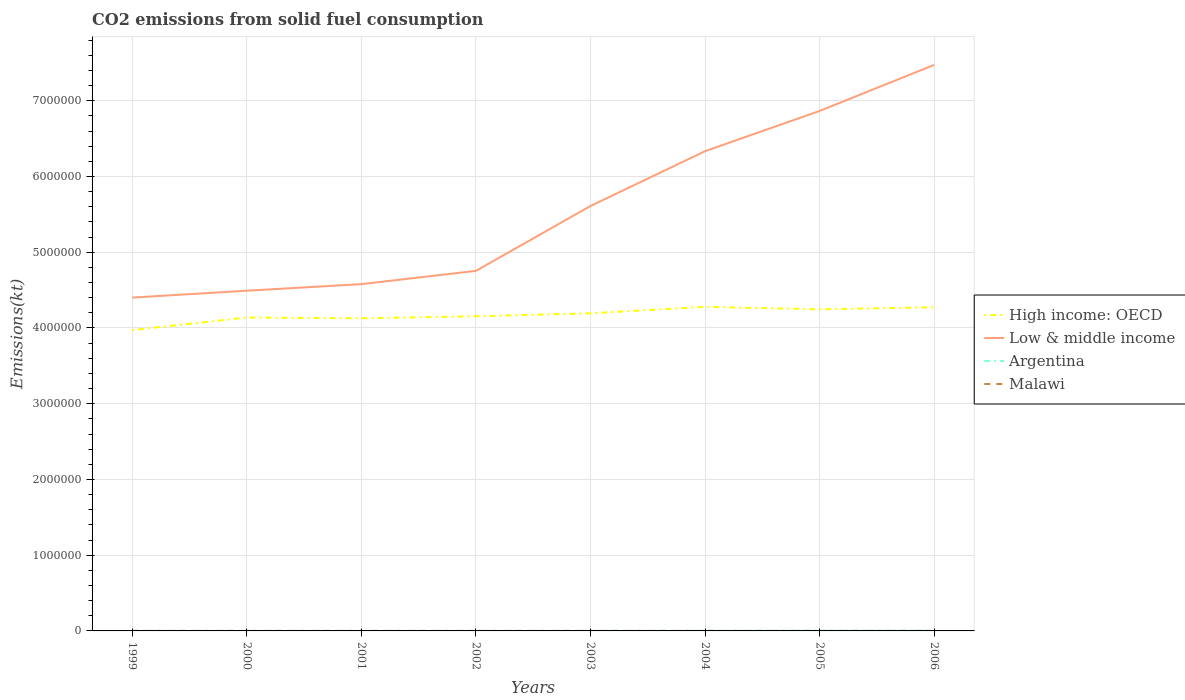Does the line corresponding to Argentina intersect with the line corresponding to Low & middle income?
Your answer should be compact. No. Across all years, what is the maximum amount of CO2 emitted in Low & middle income?
Your response must be concise. 4.40e+06. What is the total amount of CO2 emitted in Argentina in the graph?
Offer a very short reply. -891.08. What is the difference between the highest and the second highest amount of CO2 emitted in Argentina?
Your response must be concise. 2768.59. Is the amount of CO2 emitted in Argentina strictly greater than the amount of CO2 emitted in Low & middle income over the years?
Make the answer very short. Yes. How many lines are there?
Your response must be concise. 4. Are the values on the major ticks of Y-axis written in scientific E-notation?
Provide a succinct answer. No. Does the graph contain any zero values?
Offer a very short reply. No. Does the graph contain grids?
Your answer should be compact. Yes. What is the title of the graph?
Keep it short and to the point. CO2 emissions from solid fuel consumption. Does "Kenya" appear as one of the legend labels in the graph?
Give a very brief answer. No. What is the label or title of the Y-axis?
Your response must be concise. Emissions(kt). What is the Emissions(kt) of High income: OECD in 1999?
Your answer should be compact. 3.97e+06. What is the Emissions(kt) in Low & middle income in 1999?
Your response must be concise. 4.40e+06. What is the Emissions(kt) in Argentina in 1999?
Give a very brief answer. 2156.2. What is the Emissions(kt) of Malawi in 1999?
Provide a succinct answer. 143.01. What is the Emissions(kt) of High income: OECD in 2000?
Provide a short and direct response. 4.14e+06. What is the Emissions(kt) in Low & middle income in 2000?
Your answer should be very brief. 4.49e+06. What is the Emissions(kt) in Argentina in 2000?
Ensure brevity in your answer.  1657.48. What is the Emissions(kt) of Malawi in 2000?
Ensure brevity in your answer.  168.68. What is the Emissions(kt) of High income: OECD in 2001?
Keep it short and to the point. 4.13e+06. What is the Emissions(kt) of Low & middle income in 2001?
Offer a very short reply. 4.58e+06. What is the Emissions(kt) in Argentina in 2001?
Keep it short and to the point. 1290.78. What is the Emissions(kt) of Malawi in 2001?
Your response must be concise. 121.01. What is the Emissions(kt) of High income: OECD in 2002?
Offer a terse response. 4.15e+06. What is the Emissions(kt) in Low & middle income in 2002?
Your answer should be compact. 4.75e+06. What is the Emissions(kt) of Argentina in 2002?
Give a very brief answer. 1100.1. What is the Emissions(kt) of Malawi in 2002?
Your answer should be very brief. 179.68. What is the Emissions(kt) of High income: OECD in 2003?
Offer a terse response. 4.19e+06. What is the Emissions(kt) of Low & middle income in 2003?
Make the answer very short. 5.61e+06. What is the Emissions(kt) of Argentina in 2003?
Provide a succinct answer. 1991.18. What is the Emissions(kt) of Malawi in 2003?
Offer a very short reply. 168.68. What is the Emissions(kt) of High income: OECD in 2004?
Offer a terse response. 4.28e+06. What is the Emissions(kt) of Low & middle income in 2004?
Ensure brevity in your answer.  6.33e+06. What is the Emissions(kt) in Argentina in 2004?
Provide a succinct answer. 2200.2. What is the Emissions(kt) in Malawi in 2004?
Give a very brief answer. 161.35. What is the Emissions(kt) in High income: OECD in 2005?
Provide a succinct answer. 4.25e+06. What is the Emissions(kt) of Low & middle income in 2005?
Give a very brief answer. 6.87e+06. What is the Emissions(kt) of Argentina in 2005?
Your response must be concise. 3270.96. What is the Emissions(kt) in Malawi in 2005?
Provide a short and direct response. 157.68. What is the Emissions(kt) in High income: OECD in 2006?
Your answer should be very brief. 4.27e+06. What is the Emissions(kt) in Low & middle income in 2006?
Your response must be concise. 7.47e+06. What is the Emissions(kt) of Argentina in 2006?
Provide a succinct answer. 3868.68. What is the Emissions(kt) of Malawi in 2006?
Your answer should be compact. 157.68. Across all years, what is the maximum Emissions(kt) in High income: OECD?
Offer a terse response. 4.28e+06. Across all years, what is the maximum Emissions(kt) of Low & middle income?
Provide a short and direct response. 7.47e+06. Across all years, what is the maximum Emissions(kt) in Argentina?
Your answer should be very brief. 3868.68. Across all years, what is the maximum Emissions(kt) in Malawi?
Keep it short and to the point. 179.68. Across all years, what is the minimum Emissions(kt) in High income: OECD?
Ensure brevity in your answer.  3.97e+06. Across all years, what is the minimum Emissions(kt) in Low & middle income?
Your response must be concise. 4.40e+06. Across all years, what is the minimum Emissions(kt) of Argentina?
Provide a succinct answer. 1100.1. Across all years, what is the minimum Emissions(kt) of Malawi?
Make the answer very short. 121.01. What is the total Emissions(kt) of High income: OECD in the graph?
Provide a succinct answer. 3.34e+07. What is the total Emissions(kt) of Low & middle income in the graph?
Provide a succinct answer. 4.45e+07. What is the total Emissions(kt) of Argentina in the graph?
Provide a succinct answer. 1.75e+04. What is the total Emissions(kt) in Malawi in the graph?
Your answer should be compact. 1257.78. What is the difference between the Emissions(kt) in High income: OECD in 1999 and that in 2000?
Ensure brevity in your answer.  -1.65e+05. What is the difference between the Emissions(kt) of Low & middle income in 1999 and that in 2000?
Offer a very short reply. -9.06e+04. What is the difference between the Emissions(kt) of Argentina in 1999 and that in 2000?
Provide a short and direct response. 498.71. What is the difference between the Emissions(kt) in Malawi in 1999 and that in 2000?
Offer a very short reply. -25.67. What is the difference between the Emissions(kt) of High income: OECD in 1999 and that in 2001?
Provide a short and direct response. -1.56e+05. What is the difference between the Emissions(kt) of Low & middle income in 1999 and that in 2001?
Your response must be concise. -1.78e+05. What is the difference between the Emissions(kt) in Argentina in 1999 and that in 2001?
Keep it short and to the point. 865.41. What is the difference between the Emissions(kt) of Malawi in 1999 and that in 2001?
Make the answer very short. 22. What is the difference between the Emissions(kt) in High income: OECD in 1999 and that in 2002?
Provide a short and direct response. -1.82e+05. What is the difference between the Emissions(kt) in Low & middle income in 1999 and that in 2002?
Offer a terse response. -3.53e+05. What is the difference between the Emissions(kt) in Argentina in 1999 and that in 2002?
Offer a very short reply. 1056.1. What is the difference between the Emissions(kt) in Malawi in 1999 and that in 2002?
Ensure brevity in your answer.  -36.67. What is the difference between the Emissions(kt) of High income: OECD in 1999 and that in 2003?
Your response must be concise. -2.21e+05. What is the difference between the Emissions(kt) in Low & middle income in 1999 and that in 2003?
Give a very brief answer. -1.21e+06. What is the difference between the Emissions(kt) of Argentina in 1999 and that in 2003?
Provide a short and direct response. 165.01. What is the difference between the Emissions(kt) in Malawi in 1999 and that in 2003?
Give a very brief answer. -25.67. What is the difference between the Emissions(kt) of High income: OECD in 1999 and that in 2004?
Your response must be concise. -3.07e+05. What is the difference between the Emissions(kt) in Low & middle income in 1999 and that in 2004?
Your response must be concise. -1.93e+06. What is the difference between the Emissions(kt) of Argentina in 1999 and that in 2004?
Ensure brevity in your answer.  -44. What is the difference between the Emissions(kt) in Malawi in 1999 and that in 2004?
Your response must be concise. -18.34. What is the difference between the Emissions(kt) of High income: OECD in 1999 and that in 2005?
Your answer should be compact. -2.74e+05. What is the difference between the Emissions(kt) in Low & middle income in 1999 and that in 2005?
Provide a succinct answer. -2.46e+06. What is the difference between the Emissions(kt) of Argentina in 1999 and that in 2005?
Provide a short and direct response. -1114.77. What is the difference between the Emissions(kt) in Malawi in 1999 and that in 2005?
Your response must be concise. -14.67. What is the difference between the Emissions(kt) of High income: OECD in 1999 and that in 2006?
Make the answer very short. -3.01e+05. What is the difference between the Emissions(kt) of Low & middle income in 1999 and that in 2006?
Offer a very short reply. -3.07e+06. What is the difference between the Emissions(kt) in Argentina in 1999 and that in 2006?
Ensure brevity in your answer.  -1712.49. What is the difference between the Emissions(kt) of Malawi in 1999 and that in 2006?
Make the answer very short. -14.67. What is the difference between the Emissions(kt) in High income: OECD in 2000 and that in 2001?
Ensure brevity in your answer.  9845.9. What is the difference between the Emissions(kt) of Low & middle income in 2000 and that in 2001?
Offer a very short reply. -8.70e+04. What is the difference between the Emissions(kt) in Argentina in 2000 and that in 2001?
Make the answer very short. 366.7. What is the difference between the Emissions(kt) of Malawi in 2000 and that in 2001?
Your answer should be compact. 47.67. What is the difference between the Emissions(kt) of High income: OECD in 2000 and that in 2002?
Your answer should be very brief. -1.65e+04. What is the difference between the Emissions(kt) of Low & middle income in 2000 and that in 2002?
Provide a short and direct response. -2.62e+05. What is the difference between the Emissions(kt) of Argentina in 2000 and that in 2002?
Give a very brief answer. 557.38. What is the difference between the Emissions(kt) of Malawi in 2000 and that in 2002?
Provide a short and direct response. -11. What is the difference between the Emissions(kt) in High income: OECD in 2000 and that in 2003?
Offer a very short reply. -5.57e+04. What is the difference between the Emissions(kt) in Low & middle income in 2000 and that in 2003?
Your response must be concise. -1.12e+06. What is the difference between the Emissions(kt) of Argentina in 2000 and that in 2003?
Your answer should be compact. -333.7. What is the difference between the Emissions(kt) of High income: OECD in 2000 and that in 2004?
Give a very brief answer. -1.42e+05. What is the difference between the Emissions(kt) of Low & middle income in 2000 and that in 2004?
Offer a very short reply. -1.84e+06. What is the difference between the Emissions(kt) of Argentina in 2000 and that in 2004?
Offer a very short reply. -542.72. What is the difference between the Emissions(kt) of Malawi in 2000 and that in 2004?
Offer a very short reply. 7.33. What is the difference between the Emissions(kt) in High income: OECD in 2000 and that in 2005?
Give a very brief answer. -1.08e+05. What is the difference between the Emissions(kt) of Low & middle income in 2000 and that in 2005?
Offer a very short reply. -2.37e+06. What is the difference between the Emissions(kt) of Argentina in 2000 and that in 2005?
Offer a terse response. -1613.48. What is the difference between the Emissions(kt) of Malawi in 2000 and that in 2005?
Offer a very short reply. 11. What is the difference between the Emissions(kt) of High income: OECD in 2000 and that in 2006?
Your answer should be very brief. -1.36e+05. What is the difference between the Emissions(kt) of Low & middle income in 2000 and that in 2006?
Your response must be concise. -2.98e+06. What is the difference between the Emissions(kt) of Argentina in 2000 and that in 2006?
Offer a terse response. -2211.2. What is the difference between the Emissions(kt) of Malawi in 2000 and that in 2006?
Give a very brief answer. 11. What is the difference between the Emissions(kt) of High income: OECD in 2001 and that in 2002?
Ensure brevity in your answer.  -2.64e+04. What is the difference between the Emissions(kt) in Low & middle income in 2001 and that in 2002?
Ensure brevity in your answer.  -1.75e+05. What is the difference between the Emissions(kt) in Argentina in 2001 and that in 2002?
Your answer should be compact. 190.68. What is the difference between the Emissions(kt) of Malawi in 2001 and that in 2002?
Make the answer very short. -58.67. What is the difference between the Emissions(kt) in High income: OECD in 2001 and that in 2003?
Your answer should be very brief. -6.56e+04. What is the difference between the Emissions(kt) of Low & middle income in 2001 and that in 2003?
Your answer should be very brief. -1.03e+06. What is the difference between the Emissions(kt) of Argentina in 2001 and that in 2003?
Your answer should be very brief. -700.4. What is the difference between the Emissions(kt) of Malawi in 2001 and that in 2003?
Your answer should be compact. -47.67. What is the difference between the Emissions(kt) of High income: OECD in 2001 and that in 2004?
Make the answer very short. -1.51e+05. What is the difference between the Emissions(kt) of Low & middle income in 2001 and that in 2004?
Keep it short and to the point. -1.76e+06. What is the difference between the Emissions(kt) in Argentina in 2001 and that in 2004?
Keep it short and to the point. -909.42. What is the difference between the Emissions(kt) in Malawi in 2001 and that in 2004?
Your answer should be very brief. -40.34. What is the difference between the Emissions(kt) of High income: OECD in 2001 and that in 2005?
Keep it short and to the point. -1.18e+05. What is the difference between the Emissions(kt) of Low & middle income in 2001 and that in 2005?
Make the answer very short. -2.29e+06. What is the difference between the Emissions(kt) of Argentina in 2001 and that in 2005?
Provide a succinct answer. -1980.18. What is the difference between the Emissions(kt) of Malawi in 2001 and that in 2005?
Provide a succinct answer. -36.67. What is the difference between the Emissions(kt) of High income: OECD in 2001 and that in 2006?
Your answer should be very brief. -1.46e+05. What is the difference between the Emissions(kt) in Low & middle income in 2001 and that in 2006?
Provide a succinct answer. -2.90e+06. What is the difference between the Emissions(kt) in Argentina in 2001 and that in 2006?
Give a very brief answer. -2577.9. What is the difference between the Emissions(kt) of Malawi in 2001 and that in 2006?
Give a very brief answer. -36.67. What is the difference between the Emissions(kt) of High income: OECD in 2002 and that in 2003?
Offer a terse response. -3.92e+04. What is the difference between the Emissions(kt) of Low & middle income in 2002 and that in 2003?
Give a very brief answer. -8.56e+05. What is the difference between the Emissions(kt) of Argentina in 2002 and that in 2003?
Keep it short and to the point. -891.08. What is the difference between the Emissions(kt) of Malawi in 2002 and that in 2003?
Offer a terse response. 11. What is the difference between the Emissions(kt) of High income: OECD in 2002 and that in 2004?
Offer a very short reply. -1.25e+05. What is the difference between the Emissions(kt) in Low & middle income in 2002 and that in 2004?
Offer a terse response. -1.58e+06. What is the difference between the Emissions(kt) in Argentina in 2002 and that in 2004?
Make the answer very short. -1100.1. What is the difference between the Emissions(kt) in Malawi in 2002 and that in 2004?
Ensure brevity in your answer.  18.34. What is the difference between the Emissions(kt) of High income: OECD in 2002 and that in 2005?
Your answer should be compact. -9.18e+04. What is the difference between the Emissions(kt) in Low & middle income in 2002 and that in 2005?
Your answer should be very brief. -2.11e+06. What is the difference between the Emissions(kt) in Argentina in 2002 and that in 2005?
Offer a terse response. -2170.86. What is the difference between the Emissions(kt) of Malawi in 2002 and that in 2005?
Offer a terse response. 22. What is the difference between the Emissions(kt) of High income: OECD in 2002 and that in 2006?
Offer a terse response. -1.19e+05. What is the difference between the Emissions(kt) in Low & middle income in 2002 and that in 2006?
Ensure brevity in your answer.  -2.72e+06. What is the difference between the Emissions(kt) of Argentina in 2002 and that in 2006?
Offer a very short reply. -2768.59. What is the difference between the Emissions(kt) of Malawi in 2002 and that in 2006?
Your answer should be compact. 22. What is the difference between the Emissions(kt) in High income: OECD in 2003 and that in 2004?
Keep it short and to the point. -8.59e+04. What is the difference between the Emissions(kt) of Low & middle income in 2003 and that in 2004?
Your answer should be very brief. -7.24e+05. What is the difference between the Emissions(kt) in Argentina in 2003 and that in 2004?
Ensure brevity in your answer.  -209.02. What is the difference between the Emissions(kt) in Malawi in 2003 and that in 2004?
Make the answer very short. 7.33. What is the difference between the Emissions(kt) in High income: OECD in 2003 and that in 2005?
Your answer should be compact. -5.26e+04. What is the difference between the Emissions(kt) in Low & middle income in 2003 and that in 2005?
Make the answer very short. -1.26e+06. What is the difference between the Emissions(kt) of Argentina in 2003 and that in 2005?
Offer a very short reply. -1279.78. What is the difference between the Emissions(kt) of Malawi in 2003 and that in 2005?
Your answer should be compact. 11. What is the difference between the Emissions(kt) of High income: OECD in 2003 and that in 2006?
Keep it short and to the point. -8.02e+04. What is the difference between the Emissions(kt) in Low & middle income in 2003 and that in 2006?
Give a very brief answer. -1.86e+06. What is the difference between the Emissions(kt) in Argentina in 2003 and that in 2006?
Your answer should be very brief. -1877.5. What is the difference between the Emissions(kt) of Malawi in 2003 and that in 2006?
Your answer should be very brief. 11. What is the difference between the Emissions(kt) of High income: OECD in 2004 and that in 2005?
Your answer should be very brief. 3.32e+04. What is the difference between the Emissions(kt) in Low & middle income in 2004 and that in 2005?
Offer a very short reply. -5.31e+05. What is the difference between the Emissions(kt) in Argentina in 2004 and that in 2005?
Keep it short and to the point. -1070.76. What is the difference between the Emissions(kt) of Malawi in 2004 and that in 2005?
Your response must be concise. 3.67. What is the difference between the Emissions(kt) in High income: OECD in 2004 and that in 2006?
Keep it short and to the point. 5639.85. What is the difference between the Emissions(kt) of Low & middle income in 2004 and that in 2006?
Your answer should be very brief. -1.14e+06. What is the difference between the Emissions(kt) of Argentina in 2004 and that in 2006?
Offer a very short reply. -1668.48. What is the difference between the Emissions(kt) of Malawi in 2004 and that in 2006?
Offer a very short reply. 3.67. What is the difference between the Emissions(kt) in High income: OECD in 2005 and that in 2006?
Your answer should be very brief. -2.76e+04. What is the difference between the Emissions(kt) in Low & middle income in 2005 and that in 2006?
Provide a succinct answer. -6.09e+05. What is the difference between the Emissions(kt) of Argentina in 2005 and that in 2006?
Your response must be concise. -597.72. What is the difference between the Emissions(kt) of Malawi in 2005 and that in 2006?
Offer a terse response. 0. What is the difference between the Emissions(kt) in High income: OECD in 1999 and the Emissions(kt) in Low & middle income in 2000?
Offer a very short reply. -5.20e+05. What is the difference between the Emissions(kt) in High income: OECD in 1999 and the Emissions(kt) in Argentina in 2000?
Keep it short and to the point. 3.97e+06. What is the difference between the Emissions(kt) in High income: OECD in 1999 and the Emissions(kt) in Malawi in 2000?
Your answer should be compact. 3.97e+06. What is the difference between the Emissions(kt) in Low & middle income in 1999 and the Emissions(kt) in Argentina in 2000?
Make the answer very short. 4.40e+06. What is the difference between the Emissions(kt) in Low & middle income in 1999 and the Emissions(kt) in Malawi in 2000?
Keep it short and to the point. 4.40e+06. What is the difference between the Emissions(kt) of Argentina in 1999 and the Emissions(kt) of Malawi in 2000?
Make the answer very short. 1987.51. What is the difference between the Emissions(kt) of High income: OECD in 1999 and the Emissions(kt) of Low & middle income in 2001?
Provide a short and direct response. -6.07e+05. What is the difference between the Emissions(kt) in High income: OECD in 1999 and the Emissions(kt) in Argentina in 2001?
Offer a very short reply. 3.97e+06. What is the difference between the Emissions(kt) in High income: OECD in 1999 and the Emissions(kt) in Malawi in 2001?
Your response must be concise. 3.97e+06. What is the difference between the Emissions(kt) of Low & middle income in 1999 and the Emissions(kt) of Argentina in 2001?
Keep it short and to the point. 4.40e+06. What is the difference between the Emissions(kt) in Low & middle income in 1999 and the Emissions(kt) in Malawi in 2001?
Your response must be concise. 4.40e+06. What is the difference between the Emissions(kt) in Argentina in 1999 and the Emissions(kt) in Malawi in 2001?
Your answer should be very brief. 2035.18. What is the difference between the Emissions(kt) of High income: OECD in 1999 and the Emissions(kt) of Low & middle income in 2002?
Your answer should be very brief. -7.82e+05. What is the difference between the Emissions(kt) in High income: OECD in 1999 and the Emissions(kt) in Argentina in 2002?
Keep it short and to the point. 3.97e+06. What is the difference between the Emissions(kt) of High income: OECD in 1999 and the Emissions(kt) of Malawi in 2002?
Your answer should be compact. 3.97e+06. What is the difference between the Emissions(kt) in Low & middle income in 1999 and the Emissions(kt) in Argentina in 2002?
Give a very brief answer. 4.40e+06. What is the difference between the Emissions(kt) of Low & middle income in 1999 and the Emissions(kt) of Malawi in 2002?
Your answer should be very brief. 4.40e+06. What is the difference between the Emissions(kt) in Argentina in 1999 and the Emissions(kt) in Malawi in 2002?
Keep it short and to the point. 1976.51. What is the difference between the Emissions(kt) in High income: OECD in 1999 and the Emissions(kt) in Low & middle income in 2003?
Make the answer very short. -1.64e+06. What is the difference between the Emissions(kt) of High income: OECD in 1999 and the Emissions(kt) of Argentina in 2003?
Make the answer very short. 3.97e+06. What is the difference between the Emissions(kt) of High income: OECD in 1999 and the Emissions(kt) of Malawi in 2003?
Offer a terse response. 3.97e+06. What is the difference between the Emissions(kt) of Low & middle income in 1999 and the Emissions(kt) of Argentina in 2003?
Ensure brevity in your answer.  4.40e+06. What is the difference between the Emissions(kt) in Low & middle income in 1999 and the Emissions(kt) in Malawi in 2003?
Provide a succinct answer. 4.40e+06. What is the difference between the Emissions(kt) of Argentina in 1999 and the Emissions(kt) of Malawi in 2003?
Your response must be concise. 1987.51. What is the difference between the Emissions(kt) in High income: OECD in 1999 and the Emissions(kt) in Low & middle income in 2004?
Ensure brevity in your answer.  -2.36e+06. What is the difference between the Emissions(kt) of High income: OECD in 1999 and the Emissions(kt) of Argentina in 2004?
Keep it short and to the point. 3.97e+06. What is the difference between the Emissions(kt) in High income: OECD in 1999 and the Emissions(kt) in Malawi in 2004?
Your response must be concise. 3.97e+06. What is the difference between the Emissions(kt) of Low & middle income in 1999 and the Emissions(kt) of Argentina in 2004?
Offer a very short reply. 4.40e+06. What is the difference between the Emissions(kt) in Low & middle income in 1999 and the Emissions(kt) in Malawi in 2004?
Make the answer very short. 4.40e+06. What is the difference between the Emissions(kt) in Argentina in 1999 and the Emissions(kt) in Malawi in 2004?
Offer a terse response. 1994.85. What is the difference between the Emissions(kt) in High income: OECD in 1999 and the Emissions(kt) in Low & middle income in 2005?
Provide a short and direct response. -2.89e+06. What is the difference between the Emissions(kt) of High income: OECD in 1999 and the Emissions(kt) of Argentina in 2005?
Your response must be concise. 3.97e+06. What is the difference between the Emissions(kt) of High income: OECD in 1999 and the Emissions(kt) of Malawi in 2005?
Make the answer very short. 3.97e+06. What is the difference between the Emissions(kt) of Low & middle income in 1999 and the Emissions(kt) of Argentina in 2005?
Offer a terse response. 4.40e+06. What is the difference between the Emissions(kt) of Low & middle income in 1999 and the Emissions(kt) of Malawi in 2005?
Offer a very short reply. 4.40e+06. What is the difference between the Emissions(kt) in Argentina in 1999 and the Emissions(kt) in Malawi in 2005?
Make the answer very short. 1998.52. What is the difference between the Emissions(kt) of High income: OECD in 1999 and the Emissions(kt) of Low & middle income in 2006?
Your response must be concise. -3.50e+06. What is the difference between the Emissions(kt) of High income: OECD in 1999 and the Emissions(kt) of Argentina in 2006?
Your answer should be compact. 3.97e+06. What is the difference between the Emissions(kt) in High income: OECD in 1999 and the Emissions(kt) in Malawi in 2006?
Your answer should be very brief. 3.97e+06. What is the difference between the Emissions(kt) of Low & middle income in 1999 and the Emissions(kt) of Argentina in 2006?
Offer a very short reply. 4.40e+06. What is the difference between the Emissions(kt) of Low & middle income in 1999 and the Emissions(kt) of Malawi in 2006?
Ensure brevity in your answer.  4.40e+06. What is the difference between the Emissions(kt) in Argentina in 1999 and the Emissions(kt) in Malawi in 2006?
Give a very brief answer. 1998.52. What is the difference between the Emissions(kt) in High income: OECD in 2000 and the Emissions(kt) in Low & middle income in 2001?
Provide a succinct answer. -4.41e+05. What is the difference between the Emissions(kt) of High income: OECD in 2000 and the Emissions(kt) of Argentina in 2001?
Offer a very short reply. 4.14e+06. What is the difference between the Emissions(kt) of High income: OECD in 2000 and the Emissions(kt) of Malawi in 2001?
Give a very brief answer. 4.14e+06. What is the difference between the Emissions(kt) in Low & middle income in 2000 and the Emissions(kt) in Argentina in 2001?
Keep it short and to the point. 4.49e+06. What is the difference between the Emissions(kt) in Low & middle income in 2000 and the Emissions(kt) in Malawi in 2001?
Provide a succinct answer. 4.49e+06. What is the difference between the Emissions(kt) of Argentina in 2000 and the Emissions(kt) of Malawi in 2001?
Keep it short and to the point. 1536.47. What is the difference between the Emissions(kt) in High income: OECD in 2000 and the Emissions(kt) in Low & middle income in 2002?
Your answer should be compact. -6.16e+05. What is the difference between the Emissions(kt) of High income: OECD in 2000 and the Emissions(kt) of Argentina in 2002?
Your response must be concise. 4.14e+06. What is the difference between the Emissions(kt) in High income: OECD in 2000 and the Emissions(kt) in Malawi in 2002?
Give a very brief answer. 4.14e+06. What is the difference between the Emissions(kt) in Low & middle income in 2000 and the Emissions(kt) in Argentina in 2002?
Your answer should be very brief. 4.49e+06. What is the difference between the Emissions(kt) of Low & middle income in 2000 and the Emissions(kt) of Malawi in 2002?
Your response must be concise. 4.49e+06. What is the difference between the Emissions(kt) of Argentina in 2000 and the Emissions(kt) of Malawi in 2002?
Ensure brevity in your answer.  1477.8. What is the difference between the Emissions(kt) of High income: OECD in 2000 and the Emissions(kt) of Low & middle income in 2003?
Make the answer very short. -1.47e+06. What is the difference between the Emissions(kt) in High income: OECD in 2000 and the Emissions(kt) in Argentina in 2003?
Give a very brief answer. 4.14e+06. What is the difference between the Emissions(kt) of High income: OECD in 2000 and the Emissions(kt) of Malawi in 2003?
Offer a very short reply. 4.14e+06. What is the difference between the Emissions(kt) in Low & middle income in 2000 and the Emissions(kt) in Argentina in 2003?
Offer a very short reply. 4.49e+06. What is the difference between the Emissions(kt) of Low & middle income in 2000 and the Emissions(kt) of Malawi in 2003?
Ensure brevity in your answer.  4.49e+06. What is the difference between the Emissions(kt) of Argentina in 2000 and the Emissions(kt) of Malawi in 2003?
Your answer should be very brief. 1488.8. What is the difference between the Emissions(kt) in High income: OECD in 2000 and the Emissions(kt) in Low & middle income in 2004?
Make the answer very short. -2.20e+06. What is the difference between the Emissions(kt) in High income: OECD in 2000 and the Emissions(kt) in Argentina in 2004?
Provide a succinct answer. 4.14e+06. What is the difference between the Emissions(kt) of High income: OECD in 2000 and the Emissions(kt) of Malawi in 2004?
Offer a very short reply. 4.14e+06. What is the difference between the Emissions(kt) of Low & middle income in 2000 and the Emissions(kt) of Argentina in 2004?
Make the answer very short. 4.49e+06. What is the difference between the Emissions(kt) in Low & middle income in 2000 and the Emissions(kt) in Malawi in 2004?
Ensure brevity in your answer.  4.49e+06. What is the difference between the Emissions(kt) of Argentina in 2000 and the Emissions(kt) of Malawi in 2004?
Ensure brevity in your answer.  1496.14. What is the difference between the Emissions(kt) of High income: OECD in 2000 and the Emissions(kt) of Low & middle income in 2005?
Provide a succinct answer. -2.73e+06. What is the difference between the Emissions(kt) in High income: OECD in 2000 and the Emissions(kt) in Argentina in 2005?
Offer a very short reply. 4.13e+06. What is the difference between the Emissions(kt) of High income: OECD in 2000 and the Emissions(kt) of Malawi in 2005?
Provide a short and direct response. 4.14e+06. What is the difference between the Emissions(kt) in Low & middle income in 2000 and the Emissions(kt) in Argentina in 2005?
Offer a very short reply. 4.49e+06. What is the difference between the Emissions(kt) in Low & middle income in 2000 and the Emissions(kt) in Malawi in 2005?
Make the answer very short. 4.49e+06. What is the difference between the Emissions(kt) of Argentina in 2000 and the Emissions(kt) of Malawi in 2005?
Keep it short and to the point. 1499.8. What is the difference between the Emissions(kt) in High income: OECD in 2000 and the Emissions(kt) in Low & middle income in 2006?
Your answer should be compact. -3.34e+06. What is the difference between the Emissions(kt) of High income: OECD in 2000 and the Emissions(kt) of Argentina in 2006?
Ensure brevity in your answer.  4.13e+06. What is the difference between the Emissions(kt) of High income: OECD in 2000 and the Emissions(kt) of Malawi in 2006?
Provide a short and direct response. 4.14e+06. What is the difference between the Emissions(kt) of Low & middle income in 2000 and the Emissions(kt) of Argentina in 2006?
Provide a short and direct response. 4.49e+06. What is the difference between the Emissions(kt) in Low & middle income in 2000 and the Emissions(kt) in Malawi in 2006?
Your response must be concise. 4.49e+06. What is the difference between the Emissions(kt) of Argentina in 2000 and the Emissions(kt) of Malawi in 2006?
Ensure brevity in your answer.  1499.8. What is the difference between the Emissions(kt) in High income: OECD in 2001 and the Emissions(kt) in Low & middle income in 2002?
Ensure brevity in your answer.  -6.26e+05. What is the difference between the Emissions(kt) of High income: OECD in 2001 and the Emissions(kt) of Argentina in 2002?
Your response must be concise. 4.13e+06. What is the difference between the Emissions(kt) in High income: OECD in 2001 and the Emissions(kt) in Malawi in 2002?
Keep it short and to the point. 4.13e+06. What is the difference between the Emissions(kt) in Low & middle income in 2001 and the Emissions(kt) in Argentina in 2002?
Offer a very short reply. 4.58e+06. What is the difference between the Emissions(kt) in Low & middle income in 2001 and the Emissions(kt) in Malawi in 2002?
Ensure brevity in your answer.  4.58e+06. What is the difference between the Emissions(kt) in Argentina in 2001 and the Emissions(kt) in Malawi in 2002?
Your answer should be very brief. 1111.1. What is the difference between the Emissions(kt) in High income: OECD in 2001 and the Emissions(kt) in Low & middle income in 2003?
Provide a short and direct response. -1.48e+06. What is the difference between the Emissions(kt) of High income: OECD in 2001 and the Emissions(kt) of Argentina in 2003?
Provide a succinct answer. 4.13e+06. What is the difference between the Emissions(kt) of High income: OECD in 2001 and the Emissions(kt) of Malawi in 2003?
Keep it short and to the point. 4.13e+06. What is the difference between the Emissions(kt) in Low & middle income in 2001 and the Emissions(kt) in Argentina in 2003?
Offer a very short reply. 4.58e+06. What is the difference between the Emissions(kt) of Low & middle income in 2001 and the Emissions(kt) of Malawi in 2003?
Provide a short and direct response. 4.58e+06. What is the difference between the Emissions(kt) of Argentina in 2001 and the Emissions(kt) of Malawi in 2003?
Your response must be concise. 1122.1. What is the difference between the Emissions(kt) of High income: OECD in 2001 and the Emissions(kt) of Low & middle income in 2004?
Keep it short and to the point. -2.21e+06. What is the difference between the Emissions(kt) in High income: OECD in 2001 and the Emissions(kt) in Argentina in 2004?
Ensure brevity in your answer.  4.13e+06. What is the difference between the Emissions(kt) in High income: OECD in 2001 and the Emissions(kt) in Malawi in 2004?
Offer a terse response. 4.13e+06. What is the difference between the Emissions(kt) in Low & middle income in 2001 and the Emissions(kt) in Argentina in 2004?
Ensure brevity in your answer.  4.58e+06. What is the difference between the Emissions(kt) of Low & middle income in 2001 and the Emissions(kt) of Malawi in 2004?
Make the answer very short. 4.58e+06. What is the difference between the Emissions(kt) in Argentina in 2001 and the Emissions(kt) in Malawi in 2004?
Ensure brevity in your answer.  1129.44. What is the difference between the Emissions(kt) of High income: OECD in 2001 and the Emissions(kt) of Low & middle income in 2005?
Keep it short and to the point. -2.74e+06. What is the difference between the Emissions(kt) of High income: OECD in 2001 and the Emissions(kt) of Argentina in 2005?
Make the answer very short. 4.12e+06. What is the difference between the Emissions(kt) of High income: OECD in 2001 and the Emissions(kt) of Malawi in 2005?
Offer a very short reply. 4.13e+06. What is the difference between the Emissions(kt) in Low & middle income in 2001 and the Emissions(kt) in Argentina in 2005?
Your answer should be compact. 4.58e+06. What is the difference between the Emissions(kt) in Low & middle income in 2001 and the Emissions(kt) in Malawi in 2005?
Offer a very short reply. 4.58e+06. What is the difference between the Emissions(kt) in Argentina in 2001 and the Emissions(kt) in Malawi in 2005?
Make the answer very short. 1133.1. What is the difference between the Emissions(kt) in High income: OECD in 2001 and the Emissions(kt) in Low & middle income in 2006?
Your response must be concise. -3.35e+06. What is the difference between the Emissions(kt) of High income: OECD in 2001 and the Emissions(kt) of Argentina in 2006?
Your answer should be very brief. 4.12e+06. What is the difference between the Emissions(kt) in High income: OECD in 2001 and the Emissions(kt) in Malawi in 2006?
Your response must be concise. 4.13e+06. What is the difference between the Emissions(kt) in Low & middle income in 2001 and the Emissions(kt) in Argentina in 2006?
Make the answer very short. 4.58e+06. What is the difference between the Emissions(kt) of Low & middle income in 2001 and the Emissions(kt) of Malawi in 2006?
Offer a very short reply. 4.58e+06. What is the difference between the Emissions(kt) of Argentina in 2001 and the Emissions(kt) of Malawi in 2006?
Offer a terse response. 1133.1. What is the difference between the Emissions(kt) in High income: OECD in 2002 and the Emissions(kt) in Low & middle income in 2003?
Keep it short and to the point. -1.46e+06. What is the difference between the Emissions(kt) of High income: OECD in 2002 and the Emissions(kt) of Argentina in 2003?
Your answer should be very brief. 4.15e+06. What is the difference between the Emissions(kt) of High income: OECD in 2002 and the Emissions(kt) of Malawi in 2003?
Offer a terse response. 4.15e+06. What is the difference between the Emissions(kt) of Low & middle income in 2002 and the Emissions(kt) of Argentina in 2003?
Make the answer very short. 4.75e+06. What is the difference between the Emissions(kt) in Low & middle income in 2002 and the Emissions(kt) in Malawi in 2003?
Make the answer very short. 4.75e+06. What is the difference between the Emissions(kt) in Argentina in 2002 and the Emissions(kt) in Malawi in 2003?
Your answer should be compact. 931.42. What is the difference between the Emissions(kt) in High income: OECD in 2002 and the Emissions(kt) in Low & middle income in 2004?
Offer a terse response. -2.18e+06. What is the difference between the Emissions(kt) in High income: OECD in 2002 and the Emissions(kt) in Argentina in 2004?
Offer a very short reply. 4.15e+06. What is the difference between the Emissions(kt) of High income: OECD in 2002 and the Emissions(kt) of Malawi in 2004?
Make the answer very short. 4.15e+06. What is the difference between the Emissions(kt) in Low & middle income in 2002 and the Emissions(kt) in Argentina in 2004?
Offer a very short reply. 4.75e+06. What is the difference between the Emissions(kt) of Low & middle income in 2002 and the Emissions(kt) of Malawi in 2004?
Give a very brief answer. 4.75e+06. What is the difference between the Emissions(kt) of Argentina in 2002 and the Emissions(kt) of Malawi in 2004?
Your answer should be compact. 938.75. What is the difference between the Emissions(kt) of High income: OECD in 2002 and the Emissions(kt) of Low & middle income in 2005?
Provide a short and direct response. -2.71e+06. What is the difference between the Emissions(kt) of High income: OECD in 2002 and the Emissions(kt) of Argentina in 2005?
Provide a succinct answer. 4.15e+06. What is the difference between the Emissions(kt) in High income: OECD in 2002 and the Emissions(kt) in Malawi in 2005?
Keep it short and to the point. 4.15e+06. What is the difference between the Emissions(kt) in Low & middle income in 2002 and the Emissions(kt) in Argentina in 2005?
Make the answer very short. 4.75e+06. What is the difference between the Emissions(kt) of Low & middle income in 2002 and the Emissions(kt) of Malawi in 2005?
Offer a terse response. 4.75e+06. What is the difference between the Emissions(kt) in Argentina in 2002 and the Emissions(kt) in Malawi in 2005?
Ensure brevity in your answer.  942.42. What is the difference between the Emissions(kt) of High income: OECD in 2002 and the Emissions(kt) of Low & middle income in 2006?
Offer a terse response. -3.32e+06. What is the difference between the Emissions(kt) in High income: OECD in 2002 and the Emissions(kt) in Argentina in 2006?
Give a very brief answer. 4.15e+06. What is the difference between the Emissions(kt) of High income: OECD in 2002 and the Emissions(kt) of Malawi in 2006?
Ensure brevity in your answer.  4.15e+06. What is the difference between the Emissions(kt) of Low & middle income in 2002 and the Emissions(kt) of Argentina in 2006?
Offer a terse response. 4.75e+06. What is the difference between the Emissions(kt) of Low & middle income in 2002 and the Emissions(kt) of Malawi in 2006?
Offer a very short reply. 4.75e+06. What is the difference between the Emissions(kt) in Argentina in 2002 and the Emissions(kt) in Malawi in 2006?
Provide a short and direct response. 942.42. What is the difference between the Emissions(kt) of High income: OECD in 2003 and the Emissions(kt) of Low & middle income in 2004?
Offer a very short reply. -2.14e+06. What is the difference between the Emissions(kt) of High income: OECD in 2003 and the Emissions(kt) of Argentina in 2004?
Your answer should be very brief. 4.19e+06. What is the difference between the Emissions(kt) of High income: OECD in 2003 and the Emissions(kt) of Malawi in 2004?
Make the answer very short. 4.19e+06. What is the difference between the Emissions(kt) in Low & middle income in 2003 and the Emissions(kt) in Argentina in 2004?
Offer a very short reply. 5.61e+06. What is the difference between the Emissions(kt) of Low & middle income in 2003 and the Emissions(kt) of Malawi in 2004?
Your answer should be compact. 5.61e+06. What is the difference between the Emissions(kt) in Argentina in 2003 and the Emissions(kt) in Malawi in 2004?
Ensure brevity in your answer.  1829.83. What is the difference between the Emissions(kt) in High income: OECD in 2003 and the Emissions(kt) in Low & middle income in 2005?
Give a very brief answer. -2.67e+06. What is the difference between the Emissions(kt) in High income: OECD in 2003 and the Emissions(kt) in Argentina in 2005?
Provide a succinct answer. 4.19e+06. What is the difference between the Emissions(kt) of High income: OECD in 2003 and the Emissions(kt) of Malawi in 2005?
Keep it short and to the point. 4.19e+06. What is the difference between the Emissions(kt) in Low & middle income in 2003 and the Emissions(kt) in Argentina in 2005?
Your response must be concise. 5.61e+06. What is the difference between the Emissions(kt) in Low & middle income in 2003 and the Emissions(kt) in Malawi in 2005?
Provide a short and direct response. 5.61e+06. What is the difference between the Emissions(kt) of Argentina in 2003 and the Emissions(kt) of Malawi in 2005?
Provide a short and direct response. 1833.5. What is the difference between the Emissions(kt) of High income: OECD in 2003 and the Emissions(kt) of Low & middle income in 2006?
Your answer should be compact. -3.28e+06. What is the difference between the Emissions(kt) in High income: OECD in 2003 and the Emissions(kt) in Argentina in 2006?
Make the answer very short. 4.19e+06. What is the difference between the Emissions(kt) of High income: OECD in 2003 and the Emissions(kt) of Malawi in 2006?
Your answer should be compact. 4.19e+06. What is the difference between the Emissions(kt) of Low & middle income in 2003 and the Emissions(kt) of Argentina in 2006?
Your answer should be compact. 5.61e+06. What is the difference between the Emissions(kt) in Low & middle income in 2003 and the Emissions(kt) in Malawi in 2006?
Give a very brief answer. 5.61e+06. What is the difference between the Emissions(kt) in Argentina in 2003 and the Emissions(kt) in Malawi in 2006?
Your answer should be compact. 1833.5. What is the difference between the Emissions(kt) of High income: OECD in 2004 and the Emissions(kt) of Low & middle income in 2005?
Offer a very short reply. -2.59e+06. What is the difference between the Emissions(kt) of High income: OECD in 2004 and the Emissions(kt) of Argentina in 2005?
Keep it short and to the point. 4.28e+06. What is the difference between the Emissions(kt) of High income: OECD in 2004 and the Emissions(kt) of Malawi in 2005?
Your response must be concise. 4.28e+06. What is the difference between the Emissions(kt) in Low & middle income in 2004 and the Emissions(kt) in Argentina in 2005?
Offer a very short reply. 6.33e+06. What is the difference between the Emissions(kt) in Low & middle income in 2004 and the Emissions(kt) in Malawi in 2005?
Your answer should be very brief. 6.33e+06. What is the difference between the Emissions(kt) in Argentina in 2004 and the Emissions(kt) in Malawi in 2005?
Offer a very short reply. 2042.52. What is the difference between the Emissions(kt) of High income: OECD in 2004 and the Emissions(kt) of Low & middle income in 2006?
Offer a very short reply. -3.19e+06. What is the difference between the Emissions(kt) of High income: OECD in 2004 and the Emissions(kt) of Argentina in 2006?
Provide a short and direct response. 4.28e+06. What is the difference between the Emissions(kt) of High income: OECD in 2004 and the Emissions(kt) of Malawi in 2006?
Give a very brief answer. 4.28e+06. What is the difference between the Emissions(kt) in Low & middle income in 2004 and the Emissions(kt) in Argentina in 2006?
Make the answer very short. 6.33e+06. What is the difference between the Emissions(kt) of Low & middle income in 2004 and the Emissions(kt) of Malawi in 2006?
Your answer should be very brief. 6.33e+06. What is the difference between the Emissions(kt) of Argentina in 2004 and the Emissions(kt) of Malawi in 2006?
Provide a succinct answer. 2042.52. What is the difference between the Emissions(kt) in High income: OECD in 2005 and the Emissions(kt) in Low & middle income in 2006?
Your response must be concise. -3.23e+06. What is the difference between the Emissions(kt) of High income: OECD in 2005 and the Emissions(kt) of Argentina in 2006?
Provide a succinct answer. 4.24e+06. What is the difference between the Emissions(kt) in High income: OECD in 2005 and the Emissions(kt) in Malawi in 2006?
Your answer should be very brief. 4.25e+06. What is the difference between the Emissions(kt) of Low & middle income in 2005 and the Emissions(kt) of Argentina in 2006?
Provide a succinct answer. 6.86e+06. What is the difference between the Emissions(kt) in Low & middle income in 2005 and the Emissions(kt) in Malawi in 2006?
Offer a very short reply. 6.87e+06. What is the difference between the Emissions(kt) in Argentina in 2005 and the Emissions(kt) in Malawi in 2006?
Your answer should be very brief. 3113.28. What is the average Emissions(kt) of High income: OECD per year?
Offer a very short reply. 4.17e+06. What is the average Emissions(kt) of Low & middle income per year?
Your answer should be compact. 5.56e+06. What is the average Emissions(kt) of Argentina per year?
Your answer should be compact. 2191.95. What is the average Emissions(kt) of Malawi per year?
Make the answer very short. 157.22. In the year 1999, what is the difference between the Emissions(kt) of High income: OECD and Emissions(kt) of Low & middle income?
Offer a very short reply. -4.29e+05. In the year 1999, what is the difference between the Emissions(kt) in High income: OECD and Emissions(kt) in Argentina?
Provide a succinct answer. 3.97e+06. In the year 1999, what is the difference between the Emissions(kt) of High income: OECD and Emissions(kt) of Malawi?
Offer a very short reply. 3.97e+06. In the year 1999, what is the difference between the Emissions(kt) of Low & middle income and Emissions(kt) of Argentina?
Make the answer very short. 4.40e+06. In the year 1999, what is the difference between the Emissions(kt) in Low & middle income and Emissions(kt) in Malawi?
Ensure brevity in your answer.  4.40e+06. In the year 1999, what is the difference between the Emissions(kt) in Argentina and Emissions(kt) in Malawi?
Offer a terse response. 2013.18. In the year 2000, what is the difference between the Emissions(kt) of High income: OECD and Emissions(kt) of Low & middle income?
Keep it short and to the point. -3.54e+05. In the year 2000, what is the difference between the Emissions(kt) in High income: OECD and Emissions(kt) in Argentina?
Your answer should be very brief. 4.14e+06. In the year 2000, what is the difference between the Emissions(kt) in High income: OECD and Emissions(kt) in Malawi?
Keep it short and to the point. 4.14e+06. In the year 2000, what is the difference between the Emissions(kt) in Low & middle income and Emissions(kt) in Argentina?
Offer a very short reply. 4.49e+06. In the year 2000, what is the difference between the Emissions(kt) of Low & middle income and Emissions(kt) of Malawi?
Ensure brevity in your answer.  4.49e+06. In the year 2000, what is the difference between the Emissions(kt) in Argentina and Emissions(kt) in Malawi?
Keep it short and to the point. 1488.8. In the year 2001, what is the difference between the Emissions(kt) of High income: OECD and Emissions(kt) of Low & middle income?
Offer a very short reply. -4.51e+05. In the year 2001, what is the difference between the Emissions(kt) in High income: OECD and Emissions(kt) in Argentina?
Give a very brief answer. 4.13e+06. In the year 2001, what is the difference between the Emissions(kt) of High income: OECD and Emissions(kt) of Malawi?
Offer a very short reply. 4.13e+06. In the year 2001, what is the difference between the Emissions(kt) in Low & middle income and Emissions(kt) in Argentina?
Your answer should be compact. 4.58e+06. In the year 2001, what is the difference between the Emissions(kt) in Low & middle income and Emissions(kt) in Malawi?
Offer a terse response. 4.58e+06. In the year 2001, what is the difference between the Emissions(kt) in Argentina and Emissions(kt) in Malawi?
Make the answer very short. 1169.77. In the year 2002, what is the difference between the Emissions(kt) of High income: OECD and Emissions(kt) of Low & middle income?
Your answer should be compact. -6.00e+05. In the year 2002, what is the difference between the Emissions(kt) in High income: OECD and Emissions(kt) in Argentina?
Ensure brevity in your answer.  4.15e+06. In the year 2002, what is the difference between the Emissions(kt) in High income: OECD and Emissions(kt) in Malawi?
Your answer should be very brief. 4.15e+06. In the year 2002, what is the difference between the Emissions(kt) in Low & middle income and Emissions(kt) in Argentina?
Give a very brief answer. 4.75e+06. In the year 2002, what is the difference between the Emissions(kt) in Low & middle income and Emissions(kt) in Malawi?
Your response must be concise. 4.75e+06. In the year 2002, what is the difference between the Emissions(kt) of Argentina and Emissions(kt) of Malawi?
Give a very brief answer. 920.42. In the year 2003, what is the difference between the Emissions(kt) of High income: OECD and Emissions(kt) of Low & middle income?
Offer a very short reply. -1.42e+06. In the year 2003, what is the difference between the Emissions(kt) of High income: OECD and Emissions(kt) of Argentina?
Your answer should be very brief. 4.19e+06. In the year 2003, what is the difference between the Emissions(kt) in High income: OECD and Emissions(kt) in Malawi?
Ensure brevity in your answer.  4.19e+06. In the year 2003, what is the difference between the Emissions(kt) of Low & middle income and Emissions(kt) of Argentina?
Make the answer very short. 5.61e+06. In the year 2003, what is the difference between the Emissions(kt) in Low & middle income and Emissions(kt) in Malawi?
Your answer should be compact. 5.61e+06. In the year 2003, what is the difference between the Emissions(kt) of Argentina and Emissions(kt) of Malawi?
Make the answer very short. 1822.5. In the year 2004, what is the difference between the Emissions(kt) of High income: OECD and Emissions(kt) of Low & middle income?
Your answer should be very brief. -2.05e+06. In the year 2004, what is the difference between the Emissions(kt) in High income: OECD and Emissions(kt) in Argentina?
Ensure brevity in your answer.  4.28e+06. In the year 2004, what is the difference between the Emissions(kt) of High income: OECD and Emissions(kt) of Malawi?
Provide a short and direct response. 4.28e+06. In the year 2004, what is the difference between the Emissions(kt) of Low & middle income and Emissions(kt) of Argentina?
Your answer should be very brief. 6.33e+06. In the year 2004, what is the difference between the Emissions(kt) of Low & middle income and Emissions(kt) of Malawi?
Ensure brevity in your answer.  6.33e+06. In the year 2004, what is the difference between the Emissions(kt) in Argentina and Emissions(kt) in Malawi?
Ensure brevity in your answer.  2038.85. In the year 2005, what is the difference between the Emissions(kt) of High income: OECD and Emissions(kt) of Low & middle income?
Provide a succinct answer. -2.62e+06. In the year 2005, what is the difference between the Emissions(kt) in High income: OECD and Emissions(kt) in Argentina?
Make the answer very short. 4.24e+06. In the year 2005, what is the difference between the Emissions(kt) of High income: OECD and Emissions(kt) of Malawi?
Ensure brevity in your answer.  4.25e+06. In the year 2005, what is the difference between the Emissions(kt) of Low & middle income and Emissions(kt) of Argentina?
Your response must be concise. 6.86e+06. In the year 2005, what is the difference between the Emissions(kt) of Low & middle income and Emissions(kt) of Malawi?
Offer a very short reply. 6.87e+06. In the year 2005, what is the difference between the Emissions(kt) in Argentina and Emissions(kt) in Malawi?
Make the answer very short. 3113.28. In the year 2006, what is the difference between the Emissions(kt) in High income: OECD and Emissions(kt) in Low & middle income?
Offer a very short reply. -3.20e+06. In the year 2006, what is the difference between the Emissions(kt) of High income: OECD and Emissions(kt) of Argentina?
Your answer should be very brief. 4.27e+06. In the year 2006, what is the difference between the Emissions(kt) of High income: OECD and Emissions(kt) of Malawi?
Make the answer very short. 4.27e+06. In the year 2006, what is the difference between the Emissions(kt) of Low & middle income and Emissions(kt) of Argentina?
Provide a succinct answer. 7.47e+06. In the year 2006, what is the difference between the Emissions(kt) of Low & middle income and Emissions(kt) of Malawi?
Give a very brief answer. 7.47e+06. In the year 2006, what is the difference between the Emissions(kt) of Argentina and Emissions(kt) of Malawi?
Offer a terse response. 3711. What is the ratio of the Emissions(kt) in High income: OECD in 1999 to that in 2000?
Provide a succinct answer. 0.96. What is the ratio of the Emissions(kt) of Low & middle income in 1999 to that in 2000?
Offer a very short reply. 0.98. What is the ratio of the Emissions(kt) in Argentina in 1999 to that in 2000?
Ensure brevity in your answer.  1.3. What is the ratio of the Emissions(kt) in Malawi in 1999 to that in 2000?
Offer a very short reply. 0.85. What is the ratio of the Emissions(kt) of High income: OECD in 1999 to that in 2001?
Offer a very short reply. 0.96. What is the ratio of the Emissions(kt) in Low & middle income in 1999 to that in 2001?
Offer a very short reply. 0.96. What is the ratio of the Emissions(kt) of Argentina in 1999 to that in 2001?
Provide a short and direct response. 1.67. What is the ratio of the Emissions(kt) of Malawi in 1999 to that in 2001?
Your response must be concise. 1.18. What is the ratio of the Emissions(kt) of High income: OECD in 1999 to that in 2002?
Offer a very short reply. 0.96. What is the ratio of the Emissions(kt) of Low & middle income in 1999 to that in 2002?
Your response must be concise. 0.93. What is the ratio of the Emissions(kt) of Argentina in 1999 to that in 2002?
Ensure brevity in your answer.  1.96. What is the ratio of the Emissions(kt) of Malawi in 1999 to that in 2002?
Offer a very short reply. 0.8. What is the ratio of the Emissions(kt) in High income: OECD in 1999 to that in 2003?
Offer a terse response. 0.95. What is the ratio of the Emissions(kt) of Low & middle income in 1999 to that in 2003?
Provide a short and direct response. 0.78. What is the ratio of the Emissions(kt) of Argentina in 1999 to that in 2003?
Make the answer very short. 1.08. What is the ratio of the Emissions(kt) in Malawi in 1999 to that in 2003?
Your response must be concise. 0.85. What is the ratio of the Emissions(kt) of High income: OECD in 1999 to that in 2004?
Your answer should be very brief. 0.93. What is the ratio of the Emissions(kt) of Low & middle income in 1999 to that in 2004?
Ensure brevity in your answer.  0.69. What is the ratio of the Emissions(kt) in Argentina in 1999 to that in 2004?
Keep it short and to the point. 0.98. What is the ratio of the Emissions(kt) in Malawi in 1999 to that in 2004?
Your answer should be very brief. 0.89. What is the ratio of the Emissions(kt) of High income: OECD in 1999 to that in 2005?
Give a very brief answer. 0.94. What is the ratio of the Emissions(kt) in Low & middle income in 1999 to that in 2005?
Give a very brief answer. 0.64. What is the ratio of the Emissions(kt) of Argentina in 1999 to that in 2005?
Make the answer very short. 0.66. What is the ratio of the Emissions(kt) of Malawi in 1999 to that in 2005?
Your response must be concise. 0.91. What is the ratio of the Emissions(kt) of High income: OECD in 1999 to that in 2006?
Give a very brief answer. 0.93. What is the ratio of the Emissions(kt) of Low & middle income in 1999 to that in 2006?
Your answer should be compact. 0.59. What is the ratio of the Emissions(kt) of Argentina in 1999 to that in 2006?
Offer a terse response. 0.56. What is the ratio of the Emissions(kt) of Malawi in 1999 to that in 2006?
Your answer should be compact. 0.91. What is the ratio of the Emissions(kt) of High income: OECD in 2000 to that in 2001?
Make the answer very short. 1. What is the ratio of the Emissions(kt) of Argentina in 2000 to that in 2001?
Your answer should be very brief. 1.28. What is the ratio of the Emissions(kt) in Malawi in 2000 to that in 2001?
Your answer should be very brief. 1.39. What is the ratio of the Emissions(kt) in Low & middle income in 2000 to that in 2002?
Your response must be concise. 0.94. What is the ratio of the Emissions(kt) of Argentina in 2000 to that in 2002?
Ensure brevity in your answer.  1.51. What is the ratio of the Emissions(kt) of Malawi in 2000 to that in 2002?
Offer a terse response. 0.94. What is the ratio of the Emissions(kt) of High income: OECD in 2000 to that in 2003?
Keep it short and to the point. 0.99. What is the ratio of the Emissions(kt) of Low & middle income in 2000 to that in 2003?
Make the answer very short. 0.8. What is the ratio of the Emissions(kt) in Argentina in 2000 to that in 2003?
Your answer should be very brief. 0.83. What is the ratio of the Emissions(kt) of High income: OECD in 2000 to that in 2004?
Provide a short and direct response. 0.97. What is the ratio of the Emissions(kt) of Low & middle income in 2000 to that in 2004?
Offer a terse response. 0.71. What is the ratio of the Emissions(kt) in Argentina in 2000 to that in 2004?
Make the answer very short. 0.75. What is the ratio of the Emissions(kt) of Malawi in 2000 to that in 2004?
Provide a succinct answer. 1.05. What is the ratio of the Emissions(kt) of High income: OECD in 2000 to that in 2005?
Ensure brevity in your answer.  0.97. What is the ratio of the Emissions(kt) in Low & middle income in 2000 to that in 2005?
Keep it short and to the point. 0.65. What is the ratio of the Emissions(kt) of Argentina in 2000 to that in 2005?
Keep it short and to the point. 0.51. What is the ratio of the Emissions(kt) of Malawi in 2000 to that in 2005?
Provide a succinct answer. 1.07. What is the ratio of the Emissions(kt) of High income: OECD in 2000 to that in 2006?
Give a very brief answer. 0.97. What is the ratio of the Emissions(kt) of Low & middle income in 2000 to that in 2006?
Your answer should be very brief. 0.6. What is the ratio of the Emissions(kt) of Argentina in 2000 to that in 2006?
Provide a short and direct response. 0.43. What is the ratio of the Emissions(kt) in Malawi in 2000 to that in 2006?
Your answer should be compact. 1.07. What is the ratio of the Emissions(kt) in Low & middle income in 2001 to that in 2002?
Your answer should be compact. 0.96. What is the ratio of the Emissions(kt) of Argentina in 2001 to that in 2002?
Your answer should be compact. 1.17. What is the ratio of the Emissions(kt) of Malawi in 2001 to that in 2002?
Ensure brevity in your answer.  0.67. What is the ratio of the Emissions(kt) in High income: OECD in 2001 to that in 2003?
Your answer should be compact. 0.98. What is the ratio of the Emissions(kt) of Low & middle income in 2001 to that in 2003?
Keep it short and to the point. 0.82. What is the ratio of the Emissions(kt) of Argentina in 2001 to that in 2003?
Your answer should be very brief. 0.65. What is the ratio of the Emissions(kt) in Malawi in 2001 to that in 2003?
Provide a succinct answer. 0.72. What is the ratio of the Emissions(kt) of High income: OECD in 2001 to that in 2004?
Offer a terse response. 0.96. What is the ratio of the Emissions(kt) in Low & middle income in 2001 to that in 2004?
Give a very brief answer. 0.72. What is the ratio of the Emissions(kt) of Argentina in 2001 to that in 2004?
Your answer should be very brief. 0.59. What is the ratio of the Emissions(kt) of Malawi in 2001 to that in 2004?
Keep it short and to the point. 0.75. What is the ratio of the Emissions(kt) in High income: OECD in 2001 to that in 2005?
Provide a succinct answer. 0.97. What is the ratio of the Emissions(kt) in Low & middle income in 2001 to that in 2005?
Keep it short and to the point. 0.67. What is the ratio of the Emissions(kt) of Argentina in 2001 to that in 2005?
Your answer should be very brief. 0.39. What is the ratio of the Emissions(kt) in Malawi in 2001 to that in 2005?
Your answer should be compact. 0.77. What is the ratio of the Emissions(kt) in High income: OECD in 2001 to that in 2006?
Your answer should be compact. 0.97. What is the ratio of the Emissions(kt) in Low & middle income in 2001 to that in 2006?
Provide a short and direct response. 0.61. What is the ratio of the Emissions(kt) in Argentina in 2001 to that in 2006?
Offer a very short reply. 0.33. What is the ratio of the Emissions(kt) in Malawi in 2001 to that in 2006?
Your answer should be very brief. 0.77. What is the ratio of the Emissions(kt) in Low & middle income in 2002 to that in 2003?
Your response must be concise. 0.85. What is the ratio of the Emissions(kt) in Argentina in 2002 to that in 2003?
Your response must be concise. 0.55. What is the ratio of the Emissions(kt) in Malawi in 2002 to that in 2003?
Offer a very short reply. 1.07. What is the ratio of the Emissions(kt) of High income: OECD in 2002 to that in 2004?
Your response must be concise. 0.97. What is the ratio of the Emissions(kt) in Low & middle income in 2002 to that in 2004?
Give a very brief answer. 0.75. What is the ratio of the Emissions(kt) of Malawi in 2002 to that in 2004?
Give a very brief answer. 1.11. What is the ratio of the Emissions(kt) in High income: OECD in 2002 to that in 2005?
Give a very brief answer. 0.98. What is the ratio of the Emissions(kt) in Low & middle income in 2002 to that in 2005?
Offer a terse response. 0.69. What is the ratio of the Emissions(kt) in Argentina in 2002 to that in 2005?
Your answer should be compact. 0.34. What is the ratio of the Emissions(kt) in Malawi in 2002 to that in 2005?
Provide a short and direct response. 1.14. What is the ratio of the Emissions(kt) in High income: OECD in 2002 to that in 2006?
Offer a very short reply. 0.97. What is the ratio of the Emissions(kt) in Low & middle income in 2002 to that in 2006?
Provide a short and direct response. 0.64. What is the ratio of the Emissions(kt) in Argentina in 2002 to that in 2006?
Provide a short and direct response. 0.28. What is the ratio of the Emissions(kt) of Malawi in 2002 to that in 2006?
Your response must be concise. 1.14. What is the ratio of the Emissions(kt) in High income: OECD in 2003 to that in 2004?
Make the answer very short. 0.98. What is the ratio of the Emissions(kt) in Low & middle income in 2003 to that in 2004?
Your answer should be compact. 0.89. What is the ratio of the Emissions(kt) of Argentina in 2003 to that in 2004?
Ensure brevity in your answer.  0.91. What is the ratio of the Emissions(kt) of Malawi in 2003 to that in 2004?
Your response must be concise. 1.05. What is the ratio of the Emissions(kt) in High income: OECD in 2003 to that in 2005?
Provide a short and direct response. 0.99. What is the ratio of the Emissions(kt) of Low & middle income in 2003 to that in 2005?
Provide a succinct answer. 0.82. What is the ratio of the Emissions(kt) in Argentina in 2003 to that in 2005?
Your answer should be compact. 0.61. What is the ratio of the Emissions(kt) of Malawi in 2003 to that in 2005?
Keep it short and to the point. 1.07. What is the ratio of the Emissions(kt) in High income: OECD in 2003 to that in 2006?
Provide a short and direct response. 0.98. What is the ratio of the Emissions(kt) of Low & middle income in 2003 to that in 2006?
Your answer should be very brief. 0.75. What is the ratio of the Emissions(kt) of Argentina in 2003 to that in 2006?
Offer a terse response. 0.51. What is the ratio of the Emissions(kt) of Malawi in 2003 to that in 2006?
Ensure brevity in your answer.  1.07. What is the ratio of the Emissions(kt) of High income: OECD in 2004 to that in 2005?
Give a very brief answer. 1.01. What is the ratio of the Emissions(kt) in Low & middle income in 2004 to that in 2005?
Offer a terse response. 0.92. What is the ratio of the Emissions(kt) in Argentina in 2004 to that in 2005?
Your answer should be very brief. 0.67. What is the ratio of the Emissions(kt) in Malawi in 2004 to that in 2005?
Ensure brevity in your answer.  1.02. What is the ratio of the Emissions(kt) in Low & middle income in 2004 to that in 2006?
Your answer should be very brief. 0.85. What is the ratio of the Emissions(kt) of Argentina in 2004 to that in 2006?
Give a very brief answer. 0.57. What is the ratio of the Emissions(kt) of Malawi in 2004 to that in 2006?
Ensure brevity in your answer.  1.02. What is the ratio of the Emissions(kt) of Low & middle income in 2005 to that in 2006?
Your answer should be very brief. 0.92. What is the ratio of the Emissions(kt) of Argentina in 2005 to that in 2006?
Provide a succinct answer. 0.85. What is the ratio of the Emissions(kt) of Malawi in 2005 to that in 2006?
Your response must be concise. 1. What is the difference between the highest and the second highest Emissions(kt) of High income: OECD?
Your answer should be very brief. 5639.85. What is the difference between the highest and the second highest Emissions(kt) in Low & middle income?
Make the answer very short. 6.09e+05. What is the difference between the highest and the second highest Emissions(kt) in Argentina?
Provide a short and direct response. 597.72. What is the difference between the highest and the second highest Emissions(kt) of Malawi?
Your answer should be very brief. 11. What is the difference between the highest and the lowest Emissions(kt) of High income: OECD?
Provide a succinct answer. 3.07e+05. What is the difference between the highest and the lowest Emissions(kt) of Low & middle income?
Make the answer very short. 3.07e+06. What is the difference between the highest and the lowest Emissions(kt) in Argentina?
Your response must be concise. 2768.59. What is the difference between the highest and the lowest Emissions(kt) of Malawi?
Ensure brevity in your answer.  58.67. 